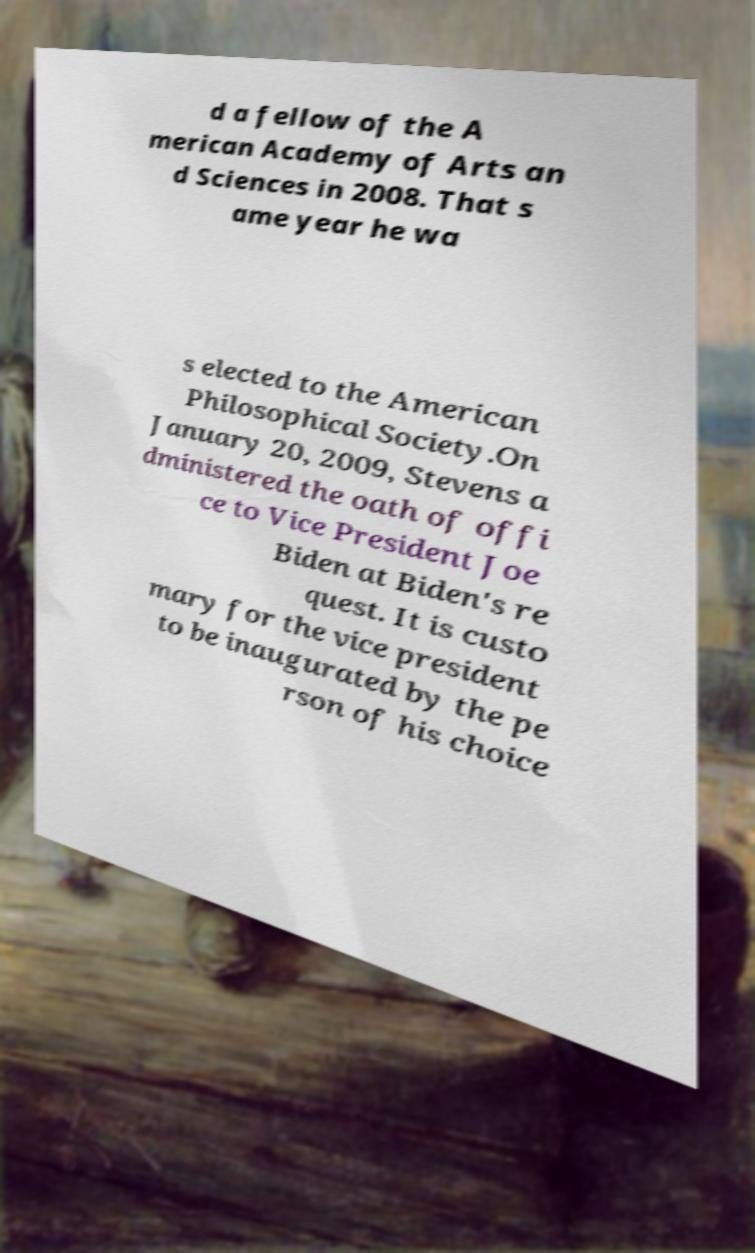Can you accurately transcribe the text from the provided image for me? d a fellow of the A merican Academy of Arts an d Sciences in 2008. That s ame year he wa s elected to the American Philosophical Society.On January 20, 2009, Stevens a dministered the oath of offi ce to Vice President Joe Biden at Biden's re quest. It is custo mary for the vice president to be inaugurated by the pe rson of his choice 